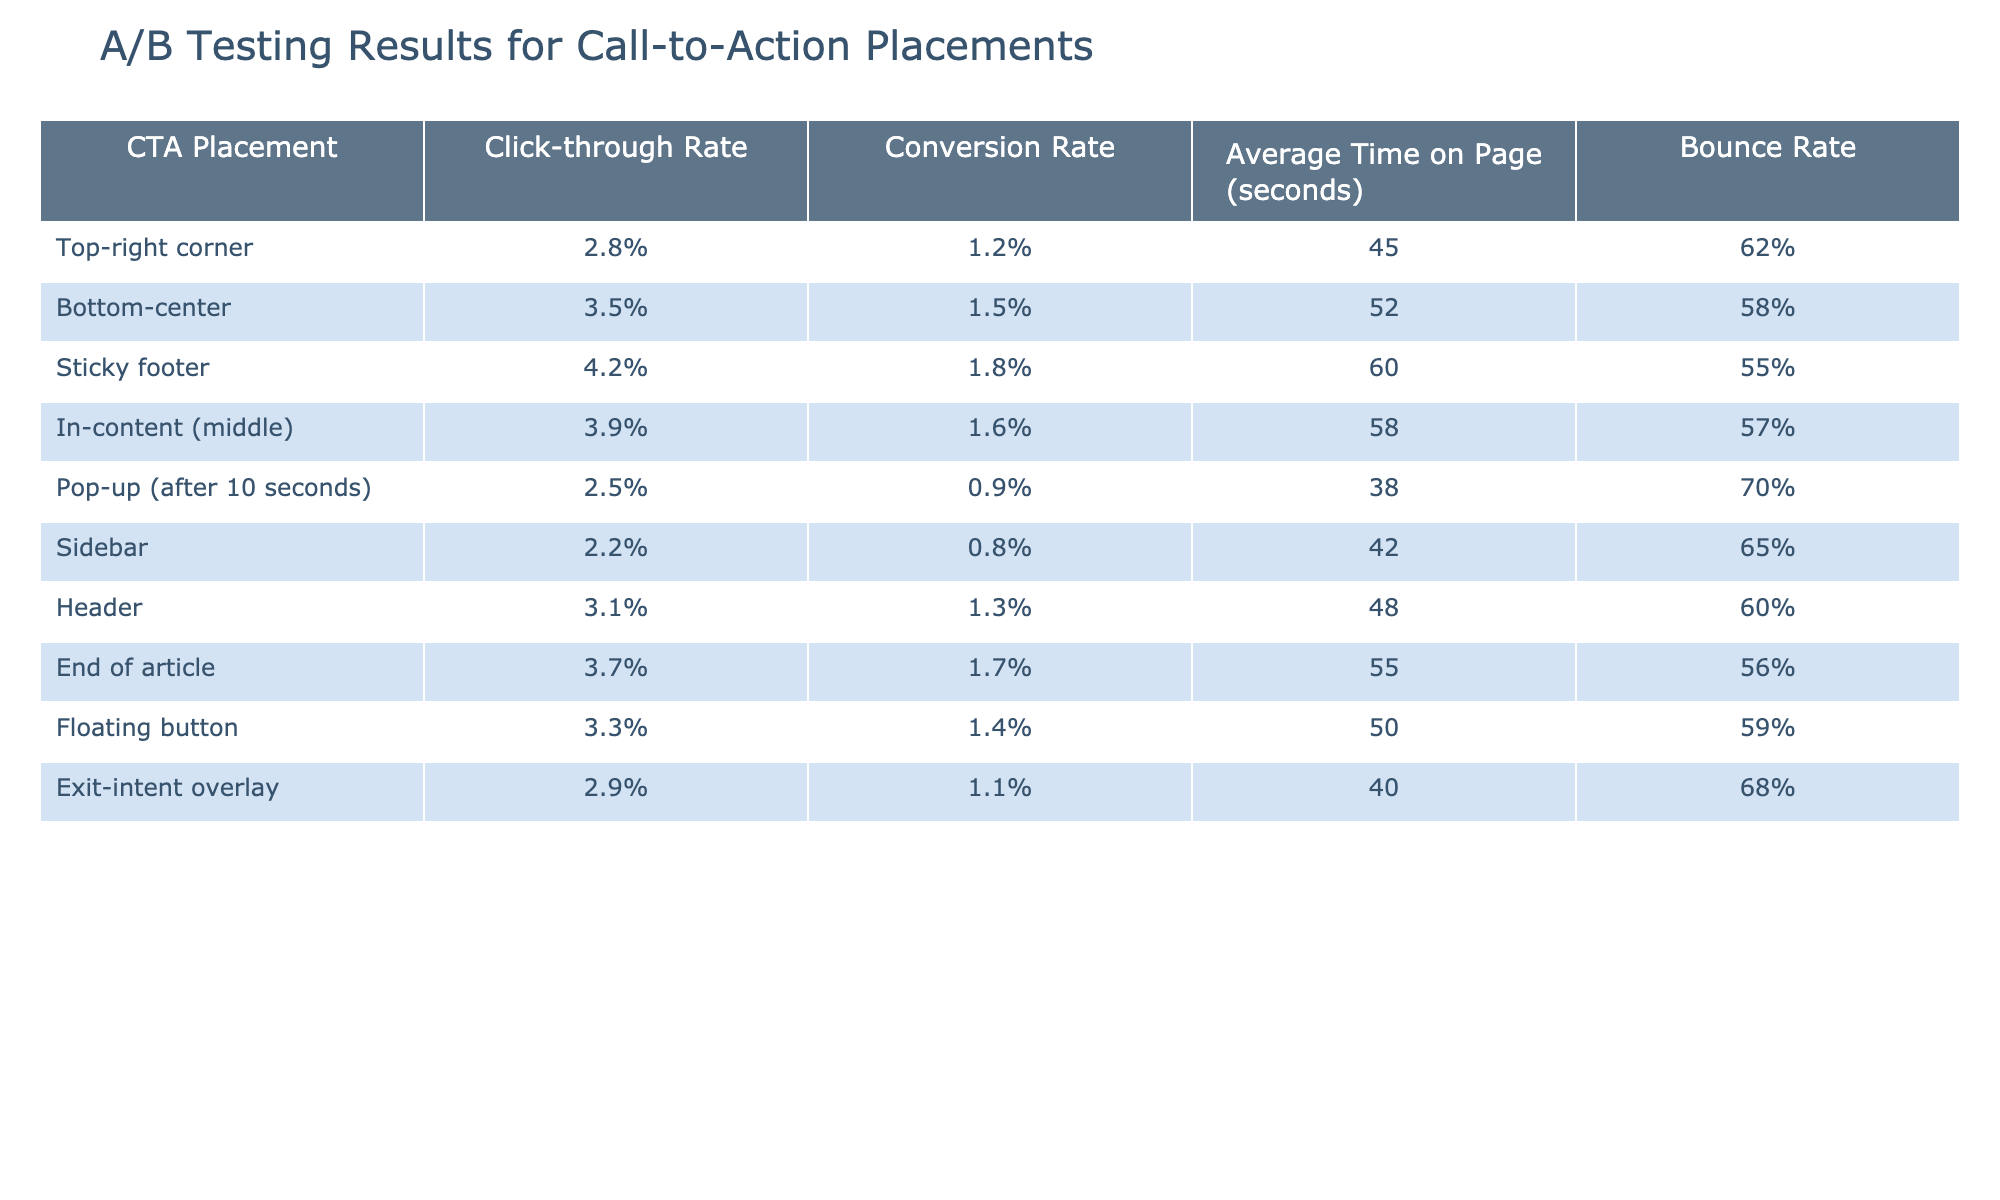What is the click-through rate for the sticky footer placement? According to the table, the click-through rate for the sticky footer placement is directly listed as 4.2%.
Answer: 4.2% Which CTA placement has the highest conversion rate? The table indicates that the sticky footer also has the highest conversion rate, reported as 1.8%.
Answer: Sticky footer What is the average time on page for the bottom-center and exit-intent overlay placements? The average time on page for the bottom-center is 52 seconds, and for the exit-intent overlay, it is 40 seconds. Adding these gives a total of 92 seconds; therefore, the average is 92/2 = 46 seconds.
Answer: 46 seconds True or False: The sidebar placement has a higher click-through rate than the header placement. The sidebar placement has a click-through rate of 2.2%, while the header placement's click-through rate is 3.1%. Since 2.2% is less than 3.1%, the statement is false.
Answer: False What is the difference in bounce rate between the sticky footer and the pop-up placements? The bounce rate for the sticky footer is 55%, and for the pop-up, it is 70%. The difference is 70% - 55% = 15%.
Answer: 15% Which three placements have click-through rates above 3%? The click-through rates above 3% are for sticky footer (4.2%), bottom-center (3.5%), and in-content (3.9%). These placements can be identified by scanning the click-through rate column.
Answer: Sticky footer, bottom-center, in-content What is the combined average time on page for the top-right corner and floating button placements? The top-right corner's average time on page is 45 seconds, and the floating button's is 50 seconds. Adding these gives 45 + 50 = 95 seconds; therefore, the average time on page is 95/2 = 47.5 seconds.
Answer: 47.5 seconds True or False: The end of article placement has a higher conversion rate than the pop-up placement. The conversion rate for the end of article placement is 1.7%, while for the pop-up, it is 0.9%. Since 1.7% is greater than 0.9%, the statement is true.
Answer: True If we were to rank the CTA placements based on click-through rates, which placement ranks second? According to the click-through rates in the table, the placements in descending order are sticky footer (4.2%), bottom-center (3.5%), and in-content (3.9%). Thus, the second-ranked placement is bottom-center with 3.5%.
Answer: Bottom-center What is the average conversion rate across all placements? To find the average conversion rate, we add all the conversion rates: 1.2% + 1.5% + 1.8% + 1.6% + 0.9% + 0.8% + 1.3% + 1.7% + 1.4% + 1.1% = 12.3%. There are 10 placements, so the average conversion rate is 12.3% / 10 = 1.23%.
Answer: 1.23% 